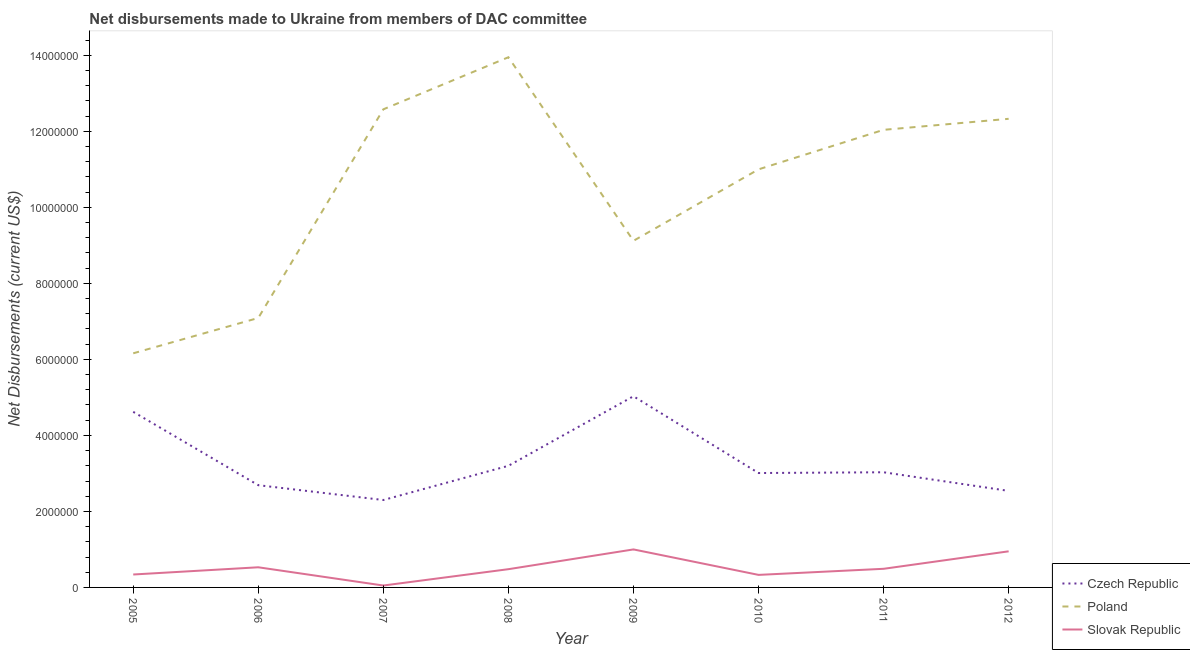How many different coloured lines are there?
Provide a succinct answer. 3. Does the line corresponding to net disbursements made by slovak republic intersect with the line corresponding to net disbursements made by poland?
Offer a very short reply. No. What is the net disbursements made by slovak republic in 2011?
Offer a terse response. 4.90e+05. Across all years, what is the maximum net disbursements made by czech republic?
Offer a very short reply. 5.03e+06. Across all years, what is the minimum net disbursements made by slovak republic?
Your response must be concise. 5.00e+04. In which year was the net disbursements made by poland maximum?
Provide a succinct answer. 2008. In which year was the net disbursements made by poland minimum?
Your response must be concise. 2005. What is the total net disbursements made by slovak republic in the graph?
Give a very brief answer. 4.17e+06. What is the difference between the net disbursements made by czech republic in 2011 and that in 2012?
Keep it short and to the point. 4.90e+05. What is the difference between the net disbursements made by slovak republic in 2012 and the net disbursements made by czech republic in 2007?
Ensure brevity in your answer.  -1.35e+06. What is the average net disbursements made by czech republic per year?
Keep it short and to the point. 3.30e+06. In the year 2011, what is the difference between the net disbursements made by slovak republic and net disbursements made by czech republic?
Give a very brief answer. -2.54e+06. What is the ratio of the net disbursements made by poland in 2006 to that in 2011?
Your answer should be very brief. 0.59. Is the net disbursements made by slovak republic in 2005 less than that in 2011?
Provide a short and direct response. Yes. Is the difference between the net disbursements made by czech republic in 2007 and 2011 greater than the difference between the net disbursements made by poland in 2007 and 2011?
Offer a very short reply. No. What is the difference between the highest and the second highest net disbursements made by slovak republic?
Keep it short and to the point. 5.00e+04. What is the difference between the highest and the lowest net disbursements made by czech republic?
Make the answer very short. 2.73e+06. Is the sum of the net disbursements made by poland in 2008 and 2010 greater than the maximum net disbursements made by czech republic across all years?
Keep it short and to the point. Yes. Is it the case that in every year, the sum of the net disbursements made by czech republic and net disbursements made by poland is greater than the net disbursements made by slovak republic?
Ensure brevity in your answer.  Yes. Does the net disbursements made by poland monotonically increase over the years?
Make the answer very short. No. Is the net disbursements made by czech republic strictly greater than the net disbursements made by poland over the years?
Provide a succinct answer. No. How many lines are there?
Provide a succinct answer. 3. How many years are there in the graph?
Make the answer very short. 8. Are the values on the major ticks of Y-axis written in scientific E-notation?
Your response must be concise. No. Does the graph contain any zero values?
Your response must be concise. No. Does the graph contain grids?
Offer a terse response. No. Where does the legend appear in the graph?
Provide a succinct answer. Bottom right. What is the title of the graph?
Your answer should be compact. Net disbursements made to Ukraine from members of DAC committee. Does "Unpaid family workers" appear as one of the legend labels in the graph?
Make the answer very short. No. What is the label or title of the X-axis?
Your answer should be very brief. Year. What is the label or title of the Y-axis?
Provide a succinct answer. Net Disbursements (current US$). What is the Net Disbursements (current US$) of Czech Republic in 2005?
Offer a very short reply. 4.62e+06. What is the Net Disbursements (current US$) in Poland in 2005?
Offer a very short reply. 6.16e+06. What is the Net Disbursements (current US$) of Slovak Republic in 2005?
Your answer should be compact. 3.40e+05. What is the Net Disbursements (current US$) in Czech Republic in 2006?
Your response must be concise. 2.69e+06. What is the Net Disbursements (current US$) in Poland in 2006?
Offer a terse response. 7.09e+06. What is the Net Disbursements (current US$) of Slovak Republic in 2006?
Your answer should be very brief. 5.30e+05. What is the Net Disbursements (current US$) in Czech Republic in 2007?
Offer a very short reply. 2.30e+06. What is the Net Disbursements (current US$) in Poland in 2007?
Ensure brevity in your answer.  1.26e+07. What is the Net Disbursements (current US$) of Czech Republic in 2008?
Offer a very short reply. 3.20e+06. What is the Net Disbursements (current US$) in Poland in 2008?
Your response must be concise. 1.40e+07. What is the Net Disbursements (current US$) of Slovak Republic in 2008?
Give a very brief answer. 4.80e+05. What is the Net Disbursements (current US$) of Czech Republic in 2009?
Provide a short and direct response. 5.03e+06. What is the Net Disbursements (current US$) of Poland in 2009?
Give a very brief answer. 9.12e+06. What is the Net Disbursements (current US$) in Czech Republic in 2010?
Keep it short and to the point. 3.01e+06. What is the Net Disbursements (current US$) in Poland in 2010?
Provide a short and direct response. 1.10e+07. What is the Net Disbursements (current US$) in Slovak Republic in 2010?
Offer a very short reply. 3.30e+05. What is the Net Disbursements (current US$) in Czech Republic in 2011?
Keep it short and to the point. 3.03e+06. What is the Net Disbursements (current US$) in Poland in 2011?
Provide a succinct answer. 1.20e+07. What is the Net Disbursements (current US$) of Czech Republic in 2012?
Offer a very short reply. 2.54e+06. What is the Net Disbursements (current US$) in Poland in 2012?
Make the answer very short. 1.23e+07. What is the Net Disbursements (current US$) in Slovak Republic in 2012?
Provide a short and direct response. 9.50e+05. Across all years, what is the maximum Net Disbursements (current US$) of Czech Republic?
Your response must be concise. 5.03e+06. Across all years, what is the maximum Net Disbursements (current US$) in Poland?
Your answer should be compact. 1.40e+07. Across all years, what is the minimum Net Disbursements (current US$) in Czech Republic?
Your response must be concise. 2.30e+06. Across all years, what is the minimum Net Disbursements (current US$) of Poland?
Keep it short and to the point. 6.16e+06. What is the total Net Disbursements (current US$) in Czech Republic in the graph?
Your answer should be very brief. 2.64e+07. What is the total Net Disbursements (current US$) in Poland in the graph?
Give a very brief answer. 8.43e+07. What is the total Net Disbursements (current US$) in Slovak Republic in the graph?
Give a very brief answer. 4.17e+06. What is the difference between the Net Disbursements (current US$) in Czech Republic in 2005 and that in 2006?
Provide a short and direct response. 1.93e+06. What is the difference between the Net Disbursements (current US$) in Poland in 2005 and that in 2006?
Your answer should be very brief. -9.30e+05. What is the difference between the Net Disbursements (current US$) of Czech Republic in 2005 and that in 2007?
Ensure brevity in your answer.  2.32e+06. What is the difference between the Net Disbursements (current US$) of Poland in 2005 and that in 2007?
Ensure brevity in your answer.  -6.42e+06. What is the difference between the Net Disbursements (current US$) of Slovak Republic in 2005 and that in 2007?
Provide a succinct answer. 2.90e+05. What is the difference between the Net Disbursements (current US$) in Czech Republic in 2005 and that in 2008?
Ensure brevity in your answer.  1.42e+06. What is the difference between the Net Disbursements (current US$) in Poland in 2005 and that in 2008?
Provide a succinct answer. -7.79e+06. What is the difference between the Net Disbursements (current US$) of Slovak Republic in 2005 and that in 2008?
Ensure brevity in your answer.  -1.40e+05. What is the difference between the Net Disbursements (current US$) in Czech Republic in 2005 and that in 2009?
Keep it short and to the point. -4.10e+05. What is the difference between the Net Disbursements (current US$) of Poland in 2005 and that in 2009?
Give a very brief answer. -2.96e+06. What is the difference between the Net Disbursements (current US$) in Slovak Republic in 2005 and that in 2009?
Your answer should be very brief. -6.60e+05. What is the difference between the Net Disbursements (current US$) of Czech Republic in 2005 and that in 2010?
Offer a terse response. 1.61e+06. What is the difference between the Net Disbursements (current US$) of Poland in 2005 and that in 2010?
Make the answer very short. -4.84e+06. What is the difference between the Net Disbursements (current US$) in Czech Republic in 2005 and that in 2011?
Provide a succinct answer. 1.59e+06. What is the difference between the Net Disbursements (current US$) of Poland in 2005 and that in 2011?
Offer a very short reply. -5.88e+06. What is the difference between the Net Disbursements (current US$) in Czech Republic in 2005 and that in 2012?
Offer a terse response. 2.08e+06. What is the difference between the Net Disbursements (current US$) of Poland in 2005 and that in 2012?
Ensure brevity in your answer.  -6.17e+06. What is the difference between the Net Disbursements (current US$) of Slovak Republic in 2005 and that in 2012?
Make the answer very short. -6.10e+05. What is the difference between the Net Disbursements (current US$) of Czech Republic in 2006 and that in 2007?
Ensure brevity in your answer.  3.90e+05. What is the difference between the Net Disbursements (current US$) in Poland in 2006 and that in 2007?
Your answer should be compact. -5.49e+06. What is the difference between the Net Disbursements (current US$) in Czech Republic in 2006 and that in 2008?
Give a very brief answer. -5.10e+05. What is the difference between the Net Disbursements (current US$) of Poland in 2006 and that in 2008?
Your answer should be compact. -6.86e+06. What is the difference between the Net Disbursements (current US$) of Czech Republic in 2006 and that in 2009?
Give a very brief answer. -2.34e+06. What is the difference between the Net Disbursements (current US$) in Poland in 2006 and that in 2009?
Make the answer very short. -2.03e+06. What is the difference between the Net Disbursements (current US$) in Slovak Republic in 2006 and that in 2009?
Ensure brevity in your answer.  -4.70e+05. What is the difference between the Net Disbursements (current US$) in Czech Republic in 2006 and that in 2010?
Offer a terse response. -3.20e+05. What is the difference between the Net Disbursements (current US$) of Poland in 2006 and that in 2010?
Offer a terse response. -3.91e+06. What is the difference between the Net Disbursements (current US$) of Czech Republic in 2006 and that in 2011?
Provide a succinct answer. -3.40e+05. What is the difference between the Net Disbursements (current US$) of Poland in 2006 and that in 2011?
Your answer should be compact. -4.95e+06. What is the difference between the Net Disbursements (current US$) in Czech Republic in 2006 and that in 2012?
Your answer should be compact. 1.50e+05. What is the difference between the Net Disbursements (current US$) in Poland in 2006 and that in 2012?
Your answer should be very brief. -5.24e+06. What is the difference between the Net Disbursements (current US$) of Slovak Republic in 2006 and that in 2012?
Make the answer very short. -4.20e+05. What is the difference between the Net Disbursements (current US$) of Czech Republic in 2007 and that in 2008?
Ensure brevity in your answer.  -9.00e+05. What is the difference between the Net Disbursements (current US$) of Poland in 2007 and that in 2008?
Give a very brief answer. -1.37e+06. What is the difference between the Net Disbursements (current US$) of Slovak Republic in 2007 and that in 2008?
Offer a terse response. -4.30e+05. What is the difference between the Net Disbursements (current US$) of Czech Republic in 2007 and that in 2009?
Make the answer very short. -2.73e+06. What is the difference between the Net Disbursements (current US$) in Poland in 2007 and that in 2009?
Provide a short and direct response. 3.46e+06. What is the difference between the Net Disbursements (current US$) in Slovak Republic in 2007 and that in 2009?
Your answer should be compact. -9.50e+05. What is the difference between the Net Disbursements (current US$) in Czech Republic in 2007 and that in 2010?
Make the answer very short. -7.10e+05. What is the difference between the Net Disbursements (current US$) in Poland in 2007 and that in 2010?
Offer a very short reply. 1.58e+06. What is the difference between the Net Disbursements (current US$) of Slovak Republic in 2007 and that in 2010?
Give a very brief answer. -2.80e+05. What is the difference between the Net Disbursements (current US$) in Czech Republic in 2007 and that in 2011?
Provide a succinct answer. -7.30e+05. What is the difference between the Net Disbursements (current US$) of Poland in 2007 and that in 2011?
Your answer should be compact. 5.40e+05. What is the difference between the Net Disbursements (current US$) of Slovak Republic in 2007 and that in 2011?
Provide a succinct answer. -4.40e+05. What is the difference between the Net Disbursements (current US$) in Czech Republic in 2007 and that in 2012?
Ensure brevity in your answer.  -2.40e+05. What is the difference between the Net Disbursements (current US$) of Poland in 2007 and that in 2012?
Your response must be concise. 2.50e+05. What is the difference between the Net Disbursements (current US$) of Slovak Republic in 2007 and that in 2012?
Your answer should be very brief. -9.00e+05. What is the difference between the Net Disbursements (current US$) of Czech Republic in 2008 and that in 2009?
Provide a succinct answer. -1.83e+06. What is the difference between the Net Disbursements (current US$) in Poland in 2008 and that in 2009?
Offer a very short reply. 4.83e+06. What is the difference between the Net Disbursements (current US$) in Slovak Republic in 2008 and that in 2009?
Offer a terse response. -5.20e+05. What is the difference between the Net Disbursements (current US$) of Czech Republic in 2008 and that in 2010?
Make the answer very short. 1.90e+05. What is the difference between the Net Disbursements (current US$) of Poland in 2008 and that in 2010?
Give a very brief answer. 2.95e+06. What is the difference between the Net Disbursements (current US$) in Slovak Republic in 2008 and that in 2010?
Your response must be concise. 1.50e+05. What is the difference between the Net Disbursements (current US$) in Czech Republic in 2008 and that in 2011?
Give a very brief answer. 1.70e+05. What is the difference between the Net Disbursements (current US$) in Poland in 2008 and that in 2011?
Your answer should be compact. 1.91e+06. What is the difference between the Net Disbursements (current US$) of Poland in 2008 and that in 2012?
Give a very brief answer. 1.62e+06. What is the difference between the Net Disbursements (current US$) in Slovak Republic in 2008 and that in 2012?
Your answer should be very brief. -4.70e+05. What is the difference between the Net Disbursements (current US$) in Czech Republic in 2009 and that in 2010?
Provide a short and direct response. 2.02e+06. What is the difference between the Net Disbursements (current US$) of Poland in 2009 and that in 2010?
Your response must be concise. -1.88e+06. What is the difference between the Net Disbursements (current US$) of Slovak Republic in 2009 and that in 2010?
Provide a short and direct response. 6.70e+05. What is the difference between the Net Disbursements (current US$) of Czech Republic in 2009 and that in 2011?
Ensure brevity in your answer.  2.00e+06. What is the difference between the Net Disbursements (current US$) in Poland in 2009 and that in 2011?
Ensure brevity in your answer.  -2.92e+06. What is the difference between the Net Disbursements (current US$) of Slovak Republic in 2009 and that in 2011?
Make the answer very short. 5.10e+05. What is the difference between the Net Disbursements (current US$) in Czech Republic in 2009 and that in 2012?
Your answer should be very brief. 2.49e+06. What is the difference between the Net Disbursements (current US$) in Poland in 2009 and that in 2012?
Keep it short and to the point. -3.21e+06. What is the difference between the Net Disbursements (current US$) of Czech Republic in 2010 and that in 2011?
Provide a short and direct response. -2.00e+04. What is the difference between the Net Disbursements (current US$) in Poland in 2010 and that in 2011?
Your response must be concise. -1.04e+06. What is the difference between the Net Disbursements (current US$) of Czech Republic in 2010 and that in 2012?
Your response must be concise. 4.70e+05. What is the difference between the Net Disbursements (current US$) in Poland in 2010 and that in 2012?
Provide a succinct answer. -1.33e+06. What is the difference between the Net Disbursements (current US$) in Slovak Republic in 2010 and that in 2012?
Provide a short and direct response. -6.20e+05. What is the difference between the Net Disbursements (current US$) in Poland in 2011 and that in 2012?
Offer a terse response. -2.90e+05. What is the difference between the Net Disbursements (current US$) in Slovak Republic in 2011 and that in 2012?
Give a very brief answer. -4.60e+05. What is the difference between the Net Disbursements (current US$) of Czech Republic in 2005 and the Net Disbursements (current US$) of Poland in 2006?
Ensure brevity in your answer.  -2.47e+06. What is the difference between the Net Disbursements (current US$) of Czech Republic in 2005 and the Net Disbursements (current US$) of Slovak Republic in 2006?
Give a very brief answer. 4.09e+06. What is the difference between the Net Disbursements (current US$) of Poland in 2005 and the Net Disbursements (current US$) of Slovak Republic in 2006?
Provide a succinct answer. 5.63e+06. What is the difference between the Net Disbursements (current US$) in Czech Republic in 2005 and the Net Disbursements (current US$) in Poland in 2007?
Your answer should be very brief. -7.96e+06. What is the difference between the Net Disbursements (current US$) of Czech Republic in 2005 and the Net Disbursements (current US$) of Slovak Republic in 2007?
Your answer should be compact. 4.57e+06. What is the difference between the Net Disbursements (current US$) in Poland in 2005 and the Net Disbursements (current US$) in Slovak Republic in 2007?
Give a very brief answer. 6.11e+06. What is the difference between the Net Disbursements (current US$) in Czech Republic in 2005 and the Net Disbursements (current US$) in Poland in 2008?
Make the answer very short. -9.33e+06. What is the difference between the Net Disbursements (current US$) in Czech Republic in 2005 and the Net Disbursements (current US$) in Slovak Republic in 2008?
Make the answer very short. 4.14e+06. What is the difference between the Net Disbursements (current US$) of Poland in 2005 and the Net Disbursements (current US$) of Slovak Republic in 2008?
Give a very brief answer. 5.68e+06. What is the difference between the Net Disbursements (current US$) of Czech Republic in 2005 and the Net Disbursements (current US$) of Poland in 2009?
Offer a very short reply. -4.50e+06. What is the difference between the Net Disbursements (current US$) of Czech Republic in 2005 and the Net Disbursements (current US$) of Slovak Republic in 2009?
Your answer should be compact. 3.62e+06. What is the difference between the Net Disbursements (current US$) of Poland in 2005 and the Net Disbursements (current US$) of Slovak Republic in 2009?
Provide a succinct answer. 5.16e+06. What is the difference between the Net Disbursements (current US$) of Czech Republic in 2005 and the Net Disbursements (current US$) of Poland in 2010?
Provide a short and direct response. -6.38e+06. What is the difference between the Net Disbursements (current US$) of Czech Republic in 2005 and the Net Disbursements (current US$) of Slovak Republic in 2010?
Make the answer very short. 4.29e+06. What is the difference between the Net Disbursements (current US$) of Poland in 2005 and the Net Disbursements (current US$) of Slovak Republic in 2010?
Give a very brief answer. 5.83e+06. What is the difference between the Net Disbursements (current US$) in Czech Republic in 2005 and the Net Disbursements (current US$) in Poland in 2011?
Keep it short and to the point. -7.42e+06. What is the difference between the Net Disbursements (current US$) of Czech Republic in 2005 and the Net Disbursements (current US$) of Slovak Republic in 2011?
Your answer should be very brief. 4.13e+06. What is the difference between the Net Disbursements (current US$) in Poland in 2005 and the Net Disbursements (current US$) in Slovak Republic in 2011?
Your answer should be compact. 5.67e+06. What is the difference between the Net Disbursements (current US$) in Czech Republic in 2005 and the Net Disbursements (current US$) in Poland in 2012?
Offer a very short reply. -7.71e+06. What is the difference between the Net Disbursements (current US$) of Czech Republic in 2005 and the Net Disbursements (current US$) of Slovak Republic in 2012?
Give a very brief answer. 3.67e+06. What is the difference between the Net Disbursements (current US$) of Poland in 2005 and the Net Disbursements (current US$) of Slovak Republic in 2012?
Ensure brevity in your answer.  5.21e+06. What is the difference between the Net Disbursements (current US$) of Czech Republic in 2006 and the Net Disbursements (current US$) of Poland in 2007?
Your answer should be compact. -9.89e+06. What is the difference between the Net Disbursements (current US$) of Czech Republic in 2006 and the Net Disbursements (current US$) of Slovak Republic in 2007?
Make the answer very short. 2.64e+06. What is the difference between the Net Disbursements (current US$) of Poland in 2006 and the Net Disbursements (current US$) of Slovak Republic in 2007?
Keep it short and to the point. 7.04e+06. What is the difference between the Net Disbursements (current US$) of Czech Republic in 2006 and the Net Disbursements (current US$) of Poland in 2008?
Offer a very short reply. -1.13e+07. What is the difference between the Net Disbursements (current US$) in Czech Republic in 2006 and the Net Disbursements (current US$) in Slovak Republic in 2008?
Offer a terse response. 2.21e+06. What is the difference between the Net Disbursements (current US$) in Poland in 2006 and the Net Disbursements (current US$) in Slovak Republic in 2008?
Keep it short and to the point. 6.61e+06. What is the difference between the Net Disbursements (current US$) of Czech Republic in 2006 and the Net Disbursements (current US$) of Poland in 2009?
Keep it short and to the point. -6.43e+06. What is the difference between the Net Disbursements (current US$) in Czech Republic in 2006 and the Net Disbursements (current US$) in Slovak Republic in 2009?
Keep it short and to the point. 1.69e+06. What is the difference between the Net Disbursements (current US$) of Poland in 2006 and the Net Disbursements (current US$) of Slovak Republic in 2009?
Provide a short and direct response. 6.09e+06. What is the difference between the Net Disbursements (current US$) of Czech Republic in 2006 and the Net Disbursements (current US$) of Poland in 2010?
Provide a short and direct response. -8.31e+06. What is the difference between the Net Disbursements (current US$) of Czech Republic in 2006 and the Net Disbursements (current US$) of Slovak Republic in 2010?
Make the answer very short. 2.36e+06. What is the difference between the Net Disbursements (current US$) of Poland in 2006 and the Net Disbursements (current US$) of Slovak Republic in 2010?
Your answer should be very brief. 6.76e+06. What is the difference between the Net Disbursements (current US$) of Czech Republic in 2006 and the Net Disbursements (current US$) of Poland in 2011?
Keep it short and to the point. -9.35e+06. What is the difference between the Net Disbursements (current US$) of Czech Republic in 2006 and the Net Disbursements (current US$) of Slovak Republic in 2011?
Your answer should be compact. 2.20e+06. What is the difference between the Net Disbursements (current US$) in Poland in 2006 and the Net Disbursements (current US$) in Slovak Republic in 2011?
Provide a succinct answer. 6.60e+06. What is the difference between the Net Disbursements (current US$) in Czech Republic in 2006 and the Net Disbursements (current US$) in Poland in 2012?
Your answer should be compact. -9.64e+06. What is the difference between the Net Disbursements (current US$) in Czech Republic in 2006 and the Net Disbursements (current US$) in Slovak Republic in 2012?
Ensure brevity in your answer.  1.74e+06. What is the difference between the Net Disbursements (current US$) of Poland in 2006 and the Net Disbursements (current US$) of Slovak Republic in 2012?
Provide a short and direct response. 6.14e+06. What is the difference between the Net Disbursements (current US$) of Czech Republic in 2007 and the Net Disbursements (current US$) of Poland in 2008?
Keep it short and to the point. -1.16e+07. What is the difference between the Net Disbursements (current US$) of Czech Republic in 2007 and the Net Disbursements (current US$) of Slovak Republic in 2008?
Give a very brief answer. 1.82e+06. What is the difference between the Net Disbursements (current US$) of Poland in 2007 and the Net Disbursements (current US$) of Slovak Republic in 2008?
Provide a succinct answer. 1.21e+07. What is the difference between the Net Disbursements (current US$) of Czech Republic in 2007 and the Net Disbursements (current US$) of Poland in 2009?
Your answer should be compact. -6.82e+06. What is the difference between the Net Disbursements (current US$) of Czech Republic in 2007 and the Net Disbursements (current US$) of Slovak Republic in 2009?
Provide a succinct answer. 1.30e+06. What is the difference between the Net Disbursements (current US$) in Poland in 2007 and the Net Disbursements (current US$) in Slovak Republic in 2009?
Provide a short and direct response. 1.16e+07. What is the difference between the Net Disbursements (current US$) in Czech Republic in 2007 and the Net Disbursements (current US$) in Poland in 2010?
Make the answer very short. -8.70e+06. What is the difference between the Net Disbursements (current US$) in Czech Republic in 2007 and the Net Disbursements (current US$) in Slovak Republic in 2010?
Offer a terse response. 1.97e+06. What is the difference between the Net Disbursements (current US$) in Poland in 2007 and the Net Disbursements (current US$) in Slovak Republic in 2010?
Make the answer very short. 1.22e+07. What is the difference between the Net Disbursements (current US$) of Czech Republic in 2007 and the Net Disbursements (current US$) of Poland in 2011?
Offer a terse response. -9.74e+06. What is the difference between the Net Disbursements (current US$) in Czech Republic in 2007 and the Net Disbursements (current US$) in Slovak Republic in 2011?
Give a very brief answer. 1.81e+06. What is the difference between the Net Disbursements (current US$) of Poland in 2007 and the Net Disbursements (current US$) of Slovak Republic in 2011?
Provide a succinct answer. 1.21e+07. What is the difference between the Net Disbursements (current US$) in Czech Republic in 2007 and the Net Disbursements (current US$) in Poland in 2012?
Your answer should be compact. -1.00e+07. What is the difference between the Net Disbursements (current US$) of Czech Republic in 2007 and the Net Disbursements (current US$) of Slovak Republic in 2012?
Offer a very short reply. 1.35e+06. What is the difference between the Net Disbursements (current US$) in Poland in 2007 and the Net Disbursements (current US$) in Slovak Republic in 2012?
Provide a short and direct response. 1.16e+07. What is the difference between the Net Disbursements (current US$) of Czech Republic in 2008 and the Net Disbursements (current US$) of Poland in 2009?
Your answer should be compact. -5.92e+06. What is the difference between the Net Disbursements (current US$) in Czech Republic in 2008 and the Net Disbursements (current US$) in Slovak Republic in 2009?
Give a very brief answer. 2.20e+06. What is the difference between the Net Disbursements (current US$) in Poland in 2008 and the Net Disbursements (current US$) in Slovak Republic in 2009?
Provide a succinct answer. 1.30e+07. What is the difference between the Net Disbursements (current US$) in Czech Republic in 2008 and the Net Disbursements (current US$) in Poland in 2010?
Keep it short and to the point. -7.80e+06. What is the difference between the Net Disbursements (current US$) in Czech Republic in 2008 and the Net Disbursements (current US$) in Slovak Republic in 2010?
Ensure brevity in your answer.  2.87e+06. What is the difference between the Net Disbursements (current US$) of Poland in 2008 and the Net Disbursements (current US$) of Slovak Republic in 2010?
Your response must be concise. 1.36e+07. What is the difference between the Net Disbursements (current US$) in Czech Republic in 2008 and the Net Disbursements (current US$) in Poland in 2011?
Offer a terse response. -8.84e+06. What is the difference between the Net Disbursements (current US$) in Czech Republic in 2008 and the Net Disbursements (current US$) in Slovak Republic in 2011?
Your answer should be very brief. 2.71e+06. What is the difference between the Net Disbursements (current US$) of Poland in 2008 and the Net Disbursements (current US$) of Slovak Republic in 2011?
Your answer should be very brief. 1.35e+07. What is the difference between the Net Disbursements (current US$) in Czech Republic in 2008 and the Net Disbursements (current US$) in Poland in 2012?
Make the answer very short. -9.13e+06. What is the difference between the Net Disbursements (current US$) in Czech Republic in 2008 and the Net Disbursements (current US$) in Slovak Republic in 2012?
Your answer should be compact. 2.25e+06. What is the difference between the Net Disbursements (current US$) in Poland in 2008 and the Net Disbursements (current US$) in Slovak Republic in 2012?
Offer a very short reply. 1.30e+07. What is the difference between the Net Disbursements (current US$) in Czech Republic in 2009 and the Net Disbursements (current US$) in Poland in 2010?
Give a very brief answer. -5.97e+06. What is the difference between the Net Disbursements (current US$) in Czech Republic in 2009 and the Net Disbursements (current US$) in Slovak Republic in 2010?
Offer a very short reply. 4.70e+06. What is the difference between the Net Disbursements (current US$) in Poland in 2009 and the Net Disbursements (current US$) in Slovak Republic in 2010?
Offer a very short reply. 8.79e+06. What is the difference between the Net Disbursements (current US$) of Czech Republic in 2009 and the Net Disbursements (current US$) of Poland in 2011?
Keep it short and to the point. -7.01e+06. What is the difference between the Net Disbursements (current US$) in Czech Republic in 2009 and the Net Disbursements (current US$) in Slovak Republic in 2011?
Your response must be concise. 4.54e+06. What is the difference between the Net Disbursements (current US$) of Poland in 2009 and the Net Disbursements (current US$) of Slovak Republic in 2011?
Offer a very short reply. 8.63e+06. What is the difference between the Net Disbursements (current US$) in Czech Republic in 2009 and the Net Disbursements (current US$) in Poland in 2012?
Offer a very short reply. -7.30e+06. What is the difference between the Net Disbursements (current US$) of Czech Republic in 2009 and the Net Disbursements (current US$) of Slovak Republic in 2012?
Your answer should be very brief. 4.08e+06. What is the difference between the Net Disbursements (current US$) of Poland in 2009 and the Net Disbursements (current US$) of Slovak Republic in 2012?
Your answer should be very brief. 8.17e+06. What is the difference between the Net Disbursements (current US$) of Czech Republic in 2010 and the Net Disbursements (current US$) of Poland in 2011?
Keep it short and to the point. -9.03e+06. What is the difference between the Net Disbursements (current US$) in Czech Republic in 2010 and the Net Disbursements (current US$) in Slovak Republic in 2011?
Your answer should be compact. 2.52e+06. What is the difference between the Net Disbursements (current US$) in Poland in 2010 and the Net Disbursements (current US$) in Slovak Republic in 2011?
Your response must be concise. 1.05e+07. What is the difference between the Net Disbursements (current US$) in Czech Republic in 2010 and the Net Disbursements (current US$) in Poland in 2012?
Offer a very short reply. -9.32e+06. What is the difference between the Net Disbursements (current US$) of Czech Republic in 2010 and the Net Disbursements (current US$) of Slovak Republic in 2012?
Your answer should be compact. 2.06e+06. What is the difference between the Net Disbursements (current US$) of Poland in 2010 and the Net Disbursements (current US$) of Slovak Republic in 2012?
Make the answer very short. 1.00e+07. What is the difference between the Net Disbursements (current US$) of Czech Republic in 2011 and the Net Disbursements (current US$) of Poland in 2012?
Your answer should be very brief. -9.30e+06. What is the difference between the Net Disbursements (current US$) of Czech Republic in 2011 and the Net Disbursements (current US$) of Slovak Republic in 2012?
Keep it short and to the point. 2.08e+06. What is the difference between the Net Disbursements (current US$) in Poland in 2011 and the Net Disbursements (current US$) in Slovak Republic in 2012?
Offer a terse response. 1.11e+07. What is the average Net Disbursements (current US$) of Czech Republic per year?
Your answer should be compact. 3.30e+06. What is the average Net Disbursements (current US$) of Poland per year?
Offer a very short reply. 1.05e+07. What is the average Net Disbursements (current US$) of Slovak Republic per year?
Keep it short and to the point. 5.21e+05. In the year 2005, what is the difference between the Net Disbursements (current US$) in Czech Republic and Net Disbursements (current US$) in Poland?
Your answer should be very brief. -1.54e+06. In the year 2005, what is the difference between the Net Disbursements (current US$) of Czech Republic and Net Disbursements (current US$) of Slovak Republic?
Offer a very short reply. 4.28e+06. In the year 2005, what is the difference between the Net Disbursements (current US$) of Poland and Net Disbursements (current US$) of Slovak Republic?
Offer a very short reply. 5.82e+06. In the year 2006, what is the difference between the Net Disbursements (current US$) of Czech Republic and Net Disbursements (current US$) of Poland?
Ensure brevity in your answer.  -4.40e+06. In the year 2006, what is the difference between the Net Disbursements (current US$) of Czech Republic and Net Disbursements (current US$) of Slovak Republic?
Provide a short and direct response. 2.16e+06. In the year 2006, what is the difference between the Net Disbursements (current US$) in Poland and Net Disbursements (current US$) in Slovak Republic?
Ensure brevity in your answer.  6.56e+06. In the year 2007, what is the difference between the Net Disbursements (current US$) of Czech Republic and Net Disbursements (current US$) of Poland?
Keep it short and to the point. -1.03e+07. In the year 2007, what is the difference between the Net Disbursements (current US$) in Czech Republic and Net Disbursements (current US$) in Slovak Republic?
Your answer should be compact. 2.25e+06. In the year 2007, what is the difference between the Net Disbursements (current US$) of Poland and Net Disbursements (current US$) of Slovak Republic?
Provide a short and direct response. 1.25e+07. In the year 2008, what is the difference between the Net Disbursements (current US$) of Czech Republic and Net Disbursements (current US$) of Poland?
Your answer should be compact. -1.08e+07. In the year 2008, what is the difference between the Net Disbursements (current US$) of Czech Republic and Net Disbursements (current US$) of Slovak Republic?
Your response must be concise. 2.72e+06. In the year 2008, what is the difference between the Net Disbursements (current US$) in Poland and Net Disbursements (current US$) in Slovak Republic?
Give a very brief answer. 1.35e+07. In the year 2009, what is the difference between the Net Disbursements (current US$) in Czech Republic and Net Disbursements (current US$) in Poland?
Give a very brief answer. -4.09e+06. In the year 2009, what is the difference between the Net Disbursements (current US$) of Czech Republic and Net Disbursements (current US$) of Slovak Republic?
Your answer should be very brief. 4.03e+06. In the year 2009, what is the difference between the Net Disbursements (current US$) in Poland and Net Disbursements (current US$) in Slovak Republic?
Your answer should be very brief. 8.12e+06. In the year 2010, what is the difference between the Net Disbursements (current US$) in Czech Republic and Net Disbursements (current US$) in Poland?
Provide a short and direct response. -7.99e+06. In the year 2010, what is the difference between the Net Disbursements (current US$) in Czech Republic and Net Disbursements (current US$) in Slovak Republic?
Ensure brevity in your answer.  2.68e+06. In the year 2010, what is the difference between the Net Disbursements (current US$) of Poland and Net Disbursements (current US$) of Slovak Republic?
Give a very brief answer. 1.07e+07. In the year 2011, what is the difference between the Net Disbursements (current US$) in Czech Republic and Net Disbursements (current US$) in Poland?
Provide a succinct answer. -9.01e+06. In the year 2011, what is the difference between the Net Disbursements (current US$) of Czech Republic and Net Disbursements (current US$) of Slovak Republic?
Keep it short and to the point. 2.54e+06. In the year 2011, what is the difference between the Net Disbursements (current US$) of Poland and Net Disbursements (current US$) of Slovak Republic?
Give a very brief answer. 1.16e+07. In the year 2012, what is the difference between the Net Disbursements (current US$) in Czech Republic and Net Disbursements (current US$) in Poland?
Give a very brief answer. -9.79e+06. In the year 2012, what is the difference between the Net Disbursements (current US$) of Czech Republic and Net Disbursements (current US$) of Slovak Republic?
Your response must be concise. 1.59e+06. In the year 2012, what is the difference between the Net Disbursements (current US$) of Poland and Net Disbursements (current US$) of Slovak Republic?
Make the answer very short. 1.14e+07. What is the ratio of the Net Disbursements (current US$) of Czech Republic in 2005 to that in 2006?
Your response must be concise. 1.72. What is the ratio of the Net Disbursements (current US$) in Poland in 2005 to that in 2006?
Give a very brief answer. 0.87. What is the ratio of the Net Disbursements (current US$) in Slovak Republic in 2005 to that in 2006?
Your answer should be compact. 0.64. What is the ratio of the Net Disbursements (current US$) of Czech Republic in 2005 to that in 2007?
Your response must be concise. 2.01. What is the ratio of the Net Disbursements (current US$) in Poland in 2005 to that in 2007?
Your response must be concise. 0.49. What is the ratio of the Net Disbursements (current US$) in Slovak Republic in 2005 to that in 2007?
Keep it short and to the point. 6.8. What is the ratio of the Net Disbursements (current US$) of Czech Republic in 2005 to that in 2008?
Your answer should be very brief. 1.44. What is the ratio of the Net Disbursements (current US$) in Poland in 2005 to that in 2008?
Your response must be concise. 0.44. What is the ratio of the Net Disbursements (current US$) in Slovak Republic in 2005 to that in 2008?
Offer a terse response. 0.71. What is the ratio of the Net Disbursements (current US$) of Czech Republic in 2005 to that in 2009?
Provide a short and direct response. 0.92. What is the ratio of the Net Disbursements (current US$) in Poland in 2005 to that in 2009?
Make the answer very short. 0.68. What is the ratio of the Net Disbursements (current US$) in Slovak Republic in 2005 to that in 2009?
Your response must be concise. 0.34. What is the ratio of the Net Disbursements (current US$) of Czech Republic in 2005 to that in 2010?
Your answer should be compact. 1.53. What is the ratio of the Net Disbursements (current US$) of Poland in 2005 to that in 2010?
Your answer should be compact. 0.56. What is the ratio of the Net Disbursements (current US$) in Slovak Republic in 2005 to that in 2010?
Provide a short and direct response. 1.03. What is the ratio of the Net Disbursements (current US$) of Czech Republic in 2005 to that in 2011?
Ensure brevity in your answer.  1.52. What is the ratio of the Net Disbursements (current US$) in Poland in 2005 to that in 2011?
Keep it short and to the point. 0.51. What is the ratio of the Net Disbursements (current US$) in Slovak Republic in 2005 to that in 2011?
Make the answer very short. 0.69. What is the ratio of the Net Disbursements (current US$) of Czech Republic in 2005 to that in 2012?
Ensure brevity in your answer.  1.82. What is the ratio of the Net Disbursements (current US$) in Poland in 2005 to that in 2012?
Make the answer very short. 0.5. What is the ratio of the Net Disbursements (current US$) in Slovak Republic in 2005 to that in 2012?
Give a very brief answer. 0.36. What is the ratio of the Net Disbursements (current US$) in Czech Republic in 2006 to that in 2007?
Make the answer very short. 1.17. What is the ratio of the Net Disbursements (current US$) in Poland in 2006 to that in 2007?
Make the answer very short. 0.56. What is the ratio of the Net Disbursements (current US$) in Czech Republic in 2006 to that in 2008?
Your answer should be compact. 0.84. What is the ratio of the Net Disbursements (current US$) in Poland in 2006 to that in 2008?
Give a very brief answer. 0.51. What is the ratio of the Net Disbursements (current US$) of Slovak Republic in 2006 to that in 2008?
Make the answer very short. 1.1. What is the ratio of the Net Disbursements (current US$) of Czech Republic in 2006 to that in 2009?
Your response must be concise. 0.53. What is the ratio of the Net Disbursements (current US$) in Poland in 2006 to that in 2009?
Your response must be concise. 0.78. What is the ratio of the Net Disbursements (current US$) in Slovak Republic in 2006 to that in 2009?
Provide a succinct answer. 0.53. What is the ratio of the Net Disbursements (current US$) of Czech Republic in 2006 to that in 2010?
Your answer should be compact. 0.89. What is the ratio of the Net Disbursements (current US$) in Poland in 2006 to that in 2010?
Your answer should be very brief. 0.64. What is the ratio of the Net Disbursements (current US$) of Slovak Republic in 2006 to that in 2010?
Your response must be concise. 1.61. What is the ratio of the Net Disbursements (current US$) of Czech Republic in 2006 to that in 2011?
Your answer should be compact. 0.89. What is the ratio of the Net Disbursements (current US$) in Poland in 2006 to that in 2011?
Provide a short and direct response. 0.59. What is the ratio of the Net Disbursements (current US$) of Slovak Republic in 2006 to that in 2011?
Your response must be concise. 1.08. What is the ratio of the Net Disbursements (current US$) of Czech Republic in 2006 to that in 2012?
Offer a very short reply. 1.06. What is the ratio of the Net Disbursements (current US$) in Poland in 2006 to that in 2012?
Keep it short and to the point. 0.57. What is the ratio of the Net Disbursements (current US$) in Slovak Republic in 2006 to that in 2012?
Offer a very short reply. 0.56. What is the ratio of the Net Disbursements (current US$) in Czech Republic in 2007 to that in 2008?
Your answer should be very brief. 0.72. What is the ratio of the Net Disbursements (current US$) of Poland in 2007 to that in 2008?
Offer a very short reply. 0.9. What is the ratio of the Net Disbursements (current US$) of Slovak Republic in 2007 to that in 2008?
Make the answer very short. 0.1. What is the ratio of the Net Disbursements (current US$) of Czech Republic in 2007 to that in 2009?
Provide a short and direct response. 0.46. What is the ratio of the Net Disbursements (current US$) in Poland in 2007 to that in 2009?
Provide a succinct answer. 1.38. What is the ratio of the Net Disbursements (current US$) of Czech Republic in 2007 to that in 2010?
Provide a short and direct response. 0.76. What is the ratio of the Net Disbursements (current US$) in Poland in 2007 to that in 2010?
Offer a terse response. 1.14. What is the ratio of the Net Disbursements (current US$) in Slovak Republic in 2007 to that in 2010?
Your response must be concise. 0.15. What is the ratio of the Net Disbursements (current US$) of Czech Republic in 2007 to that in 2011?
Make the answer very short. 0.76. What is the ratio of the Net Disbursements (current US$) in Poland in 2007 to that in 2011?
Offer a terse response. 1.04. What is the ratio of the Net Disbursements (current US$) in Slovak Republic in 2007 to that in 2011?
Give a very brief answer. 0.1. What is the ratio of the Net Disbursements (current US$) in Czech Republic in 2007 to that in 2012?
Provide a short and direct response. 0.91. What is the ratio of the Net Disbursements (current US$) of Poland in 2007 to that in 2012?
Your answer should be compact. 1.02. What is the ratio of the Net Disbursements (current US$) in Slovak Republic in 2007 to that in 2012?
Ensure brevity in your answer.  0.05. What is the ratio of the Net Disbursements (current US$) in Czech Republic in 2008 to that in 2009?
Your response must be concise. 0.64. What is the ratio of the Net Disbursements (current US$) in Poland in 2008 to that in 2009?
Make the answer very short. 1.53. What is the ratio of the Net Disbursements (current US$) in Slovak Republic in 2008 to that in 2009?
Give a very brief answer. 0.48. What is the ratio of the Net Disbursements (current US$) of Czech Republic in 2008 to that in 2010?
Your answer should be compact. 1.06. What is the ratio of the Net Disbursements (current US$) in Poland in 2008 to that in 2010?
Your answer should be very brief. 1.27. What is the ratio of the Net Disbursements (current US$) of Slovak Republic in 2008 to that in 2010?
Offer a very short reply. 1.45. What is the ratio of the Net Disbursements (current US$) of Czech Republic in 2008 to that in 2011?
Ensure brevity in your answer.  1.06. What is the ratio of the Net Disbursements (current US$) in Poland in 2008 to that in 2011?
Offer a terse response. 1.16. What is the ratio of the Net Disbursements (current US$) in Slovak Republic in 2008 to that in 2011?
Provide a succinct answer. 0.98. What is the ratio of the Net Disbursements (current US$) of Czech Republic in 2008 to that in 2012?
Your response must be concise. 1.26. What is the ratio of the Net Disbursements (current US$) of Poland in 2008 to that in 2012?
Ensure brevity in your answer.  1.13. What is the ratio of the Net Disbursements (current US$) in Slovak Republic in 2008 to that in 2012?
Your response must be concise. 0.51. What is the ratio of the Net Disbursements (current US$) in Czech Republic in 2009 to that in 2010?
Offer a terse response. 1.67. What is the ratio of the Net Disbursements (current US$) in Poland in 2009 to that in 2010?
Give a very brief answer. 0.83. What is the ratio of the Net Disbursements (current US$) in Slovak Republic in 2009 to that in 2010?
Your answer should be very brief. 3.03. What is the ratio of the Net Disbursements (current US$) of Czech Republic in 2009 to that in 2011?
Your answer should be compact. 1.66. What is the ratio of the Net Disbursements (current US$) in Poland in 2009 to that in 2011?
Provide a succinct answer. 0.76. What is the ratio of the Net Disbursements (current US$) of Slovak Republic in 2009 to that in 2011?
Offer a terse response. 2.04. What is the ratio of the Net Disbursements (current US$) in Czech Republic in 2009 to that in 2012?
Ensure brevity in your answer.  1.98. What is the ratio of the Net Disbursements (current US$) in Poland in 2009 to that in 2012?
Provide a short and direct response. 0.74. What is the ratio of the Net Disbursements (current US$) of Slovak Republic in 2009 to that in 2012?
Offer a terse response. 1.05. What is the ratio of the Net Disbursements (current US$) of Czech Republic in 2010 to that in 2011?
Give a very brief answer. 0.99. What is the ratio of the Net Disbursements (current US$) in Poland in 2010 to that in 2011?
Your answer should be compact. 0.91. What is the ratio of the Net Disbursements (current US$) in Slovak Republic in 2010 to that in 2011?
Ensure brevity in your answer.  0.67. What is the ratio of the Net Disbursements (current US$) of Czech Republic in 2010 to that in 2012?
Offer a terse response. 1.19. What is the ratio of the Net Disbursements (current US$) of Poland in 2010 to that in 2012?
Provide a succinct answer. 0.89. What is the ratio of the Net Disbursements (current US$) of Slovak Republic in 2010 to that in 2012?
Make the answer very short. 0.35. What is the ratio of the Net Disbursements (current US$) in Czech Republic in 2011 to that in 2012?
Your answer should be very brief. 1.19. What is the ratio of the Net Disbursements (current US$) of Poland in 2011 to that in 2012?
Your answer should be very brief. 0.98. What is the ratio of the Net Disbursements (current US$) of Slovak Republic in 2011 to that in 2012?
Keep it short and to the point. 0.52. What is the difference between the highest and the second highest Net Disbursements (current US$) of Czech Republic?
Make the answer very short. 4.10e+05. What is the difference between the highest and the second highest Net Disbursements (current US$) in Poland?
Make the answer very short. 1.37e+06. What is the difference between the highest and the lowest Net Disbursements (current US$) of Czech Republic?
Your response must be concise. 2.73e+06. What is the difference between the highest and the lowest Net Disbursements (current US$) of Poland?
Your answer should be compact. 7.79e+06. What is the difference between the highest and the lowest Net Disbursements (current US$) of Slovak Republic?
Your response must be concise. 9.50e+05. 